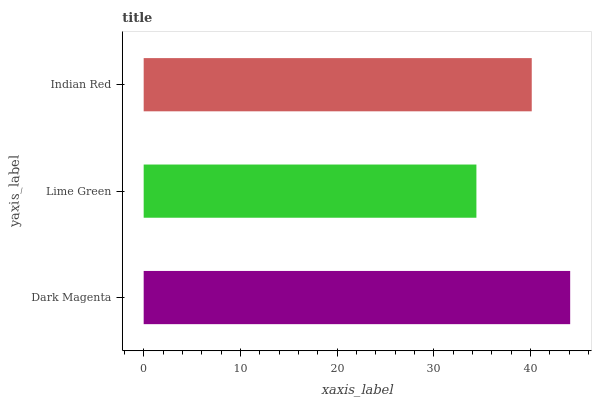Is Lime Green the minimum?
Answer yes or no. Yes. Is Dark Magenta the maximum?
Answer yes or no. Yes. Is Indian Red the minimum?
Answer yes or no. No. Is Indian Red the maximum?
Answer yes or no. No. Is Indian Red greater than Lime Green?
Answer yes or no. Yes. Is Lime Green less than Indian Red?
Answer yes or no. Yes. Is Lime Green greater than Indian Red?
Answer yes or no. No. Is Indian Red less than Lime Green?
Answer yes or no. No. Is Indian Red the high median?
Answer yes or no. Yes. Is Indian Red the low median?
Answer yes or no. Yes. Is Lime Green the high median?
Answer yes or no. No. Is Lime Green the low median?
Answer yes or no. No. 